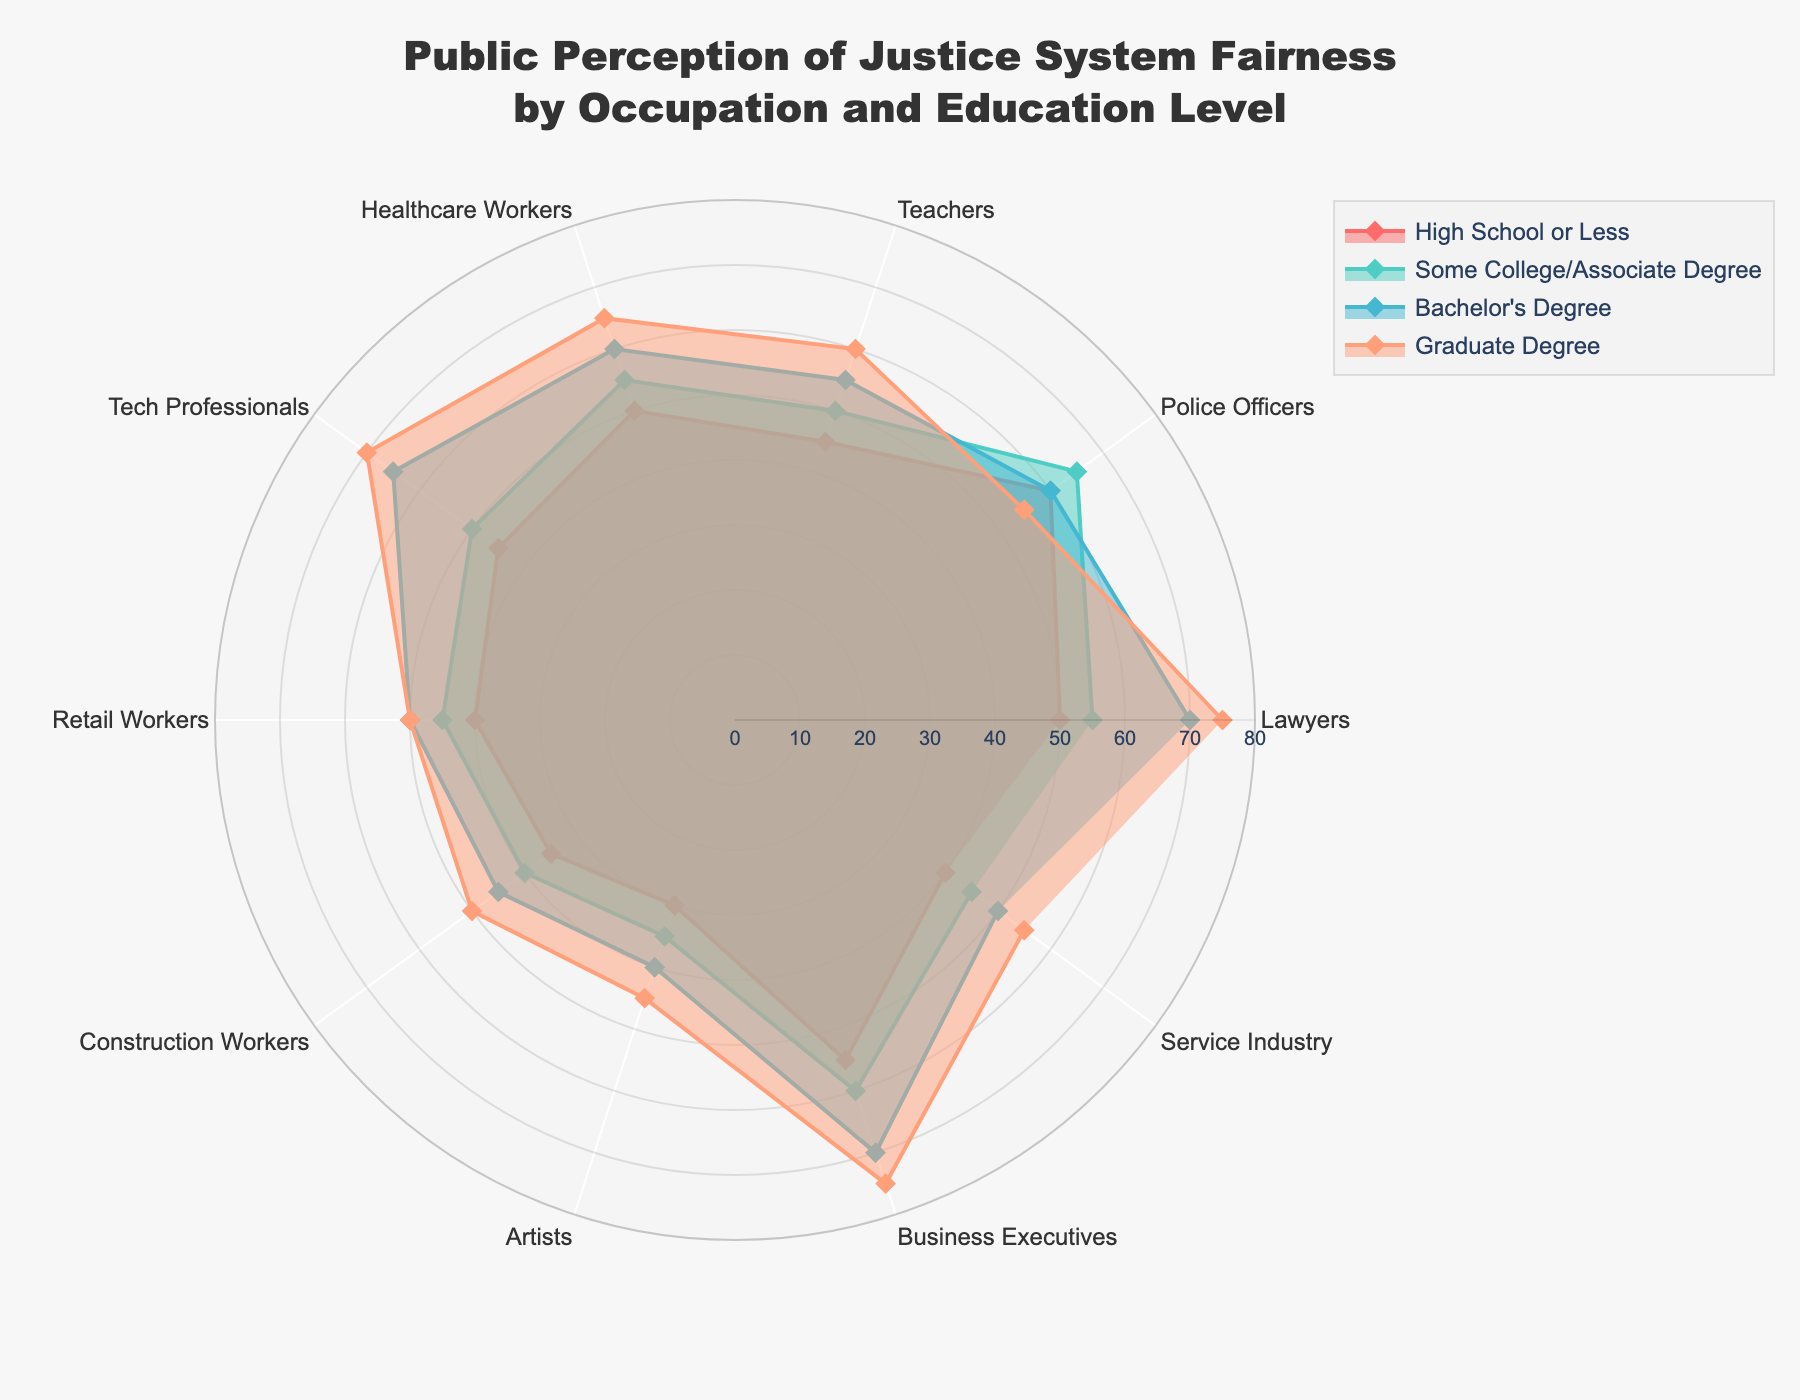Which occupation has the highest perception of justice system fairness at the Graduate Degree level? By looking at the radar chart, we can see that the Graduate Degree level for Business Executives and Lawyers reach up to the highest values. We compare these groups, and the peak value observed is 75 for both occupations.
Answer: Business Executives and Lawyers Which occupation shows the lowest perception of the justice system fairness at the High School or Less level? On the radar chart, examining the High School or Less data reveals that Artists have the lowest perception score, indicated by the smallest radius.
Answer: Artists What is the average perception of justice system fairness for Retail Workers across all education levels? The scores for Retail Workers are 40, 45, 50, and 50 for the respective education levels. Adding these values and dividing by 4 gives (40 + 45 + 50 + 50) / 4 = 185 / 4.
Answer: 46.25 Which education level shows the highest variation in perception among different occupations? By observing the difference in lengths of the data lines for each education level, the Bachelor's Degree level shows a wide range from the lowest (Artists at 40) to the highest (Lawyers at 70).
Answer: Bachelor's Degree How does the perception of fairness for Police Officers at the High School or Less level compare to Healthcare Workers at the same education level? The radar chart indicates that the perception score for Police Officers is 60, while for Healthcare Workers, it is 50. Therefore, Police Officers have a higher perception of fairness.
Answer: Police Officers perceive it higher Which two occupations have perception values that are closest to each other at the Some College/Associate Degree level? The radar chart shows that Tech Professionals and Teachers have closest scores at the Some College/Associate Degree level, both having values of 50 and 55 respectively.
Answer: Tech Professionals and Teachers What is the range of perception values for Construction Workers across all education levels? The values for Construction Workers are 35, 40, 45, and 50. The range is calculated by subtracting the smallest value from the largest, which is 50 - 35.
Answer: 15 Is the perception of justice system fairness for Teachers at the Graduate Degree level higher or lower than for Service Industry workers at the same level? On the radar chart, the Graduate Degree level for Teachers is at 60, while for Service Industry workers, it is 55. Therefore, Teachers have a higher perception of fairness.
Answer: Higher Which occupation's perception scores tend to decrease as the education level increases? The radar chart demonstrates that Police Officers' perception scores follow a decreasing trend as the education level transitions from High School or Less to Graduate Degree (60, 65, 60, 55).
Answer: Police Officers For Artists, what is the difference in perception scores between the Graduate Degree and High School or Less levels? The radar chart shows that Artists have scores of 45 for Graduate Degree and 30 for High School or Less, so the difference is 45 - 30.
Answer: 15 